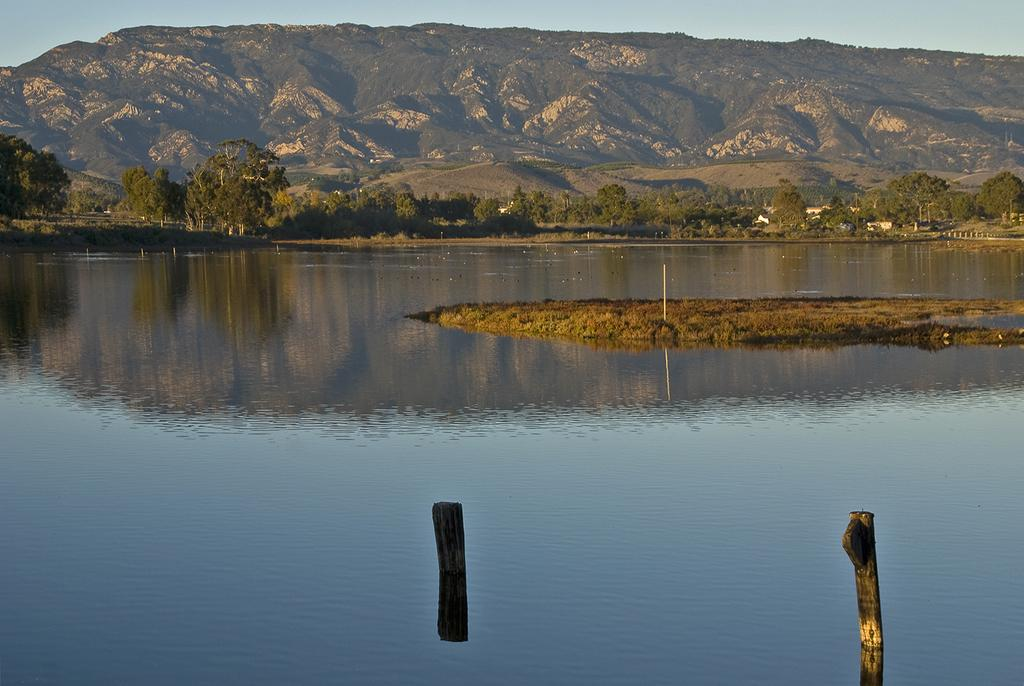What can be seen in the image? Water is visible in the image. What is in the background of the image? There are mountains, trees, poles, and the sky visible in the background of the image. What type of vegetable is being prepared on the floor in the image? There is no floor or vegetable present in the image; it features water and a background with mountains, trees, poles, and the sky. 